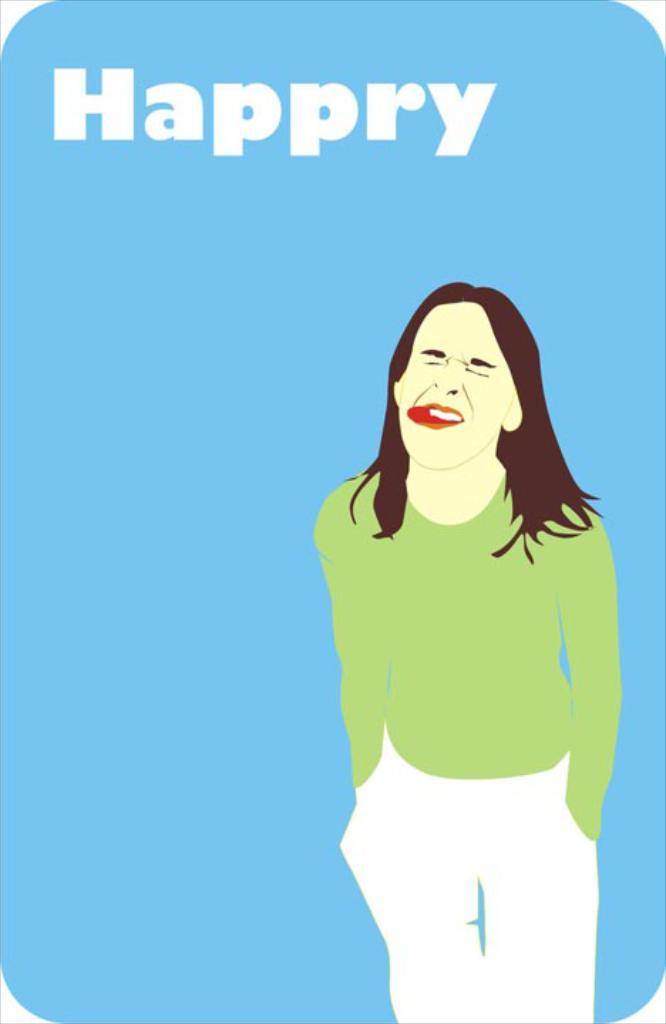<image>
Present a compact description of the photo's key features. the word happry is on the blue surface with a girl's photo 